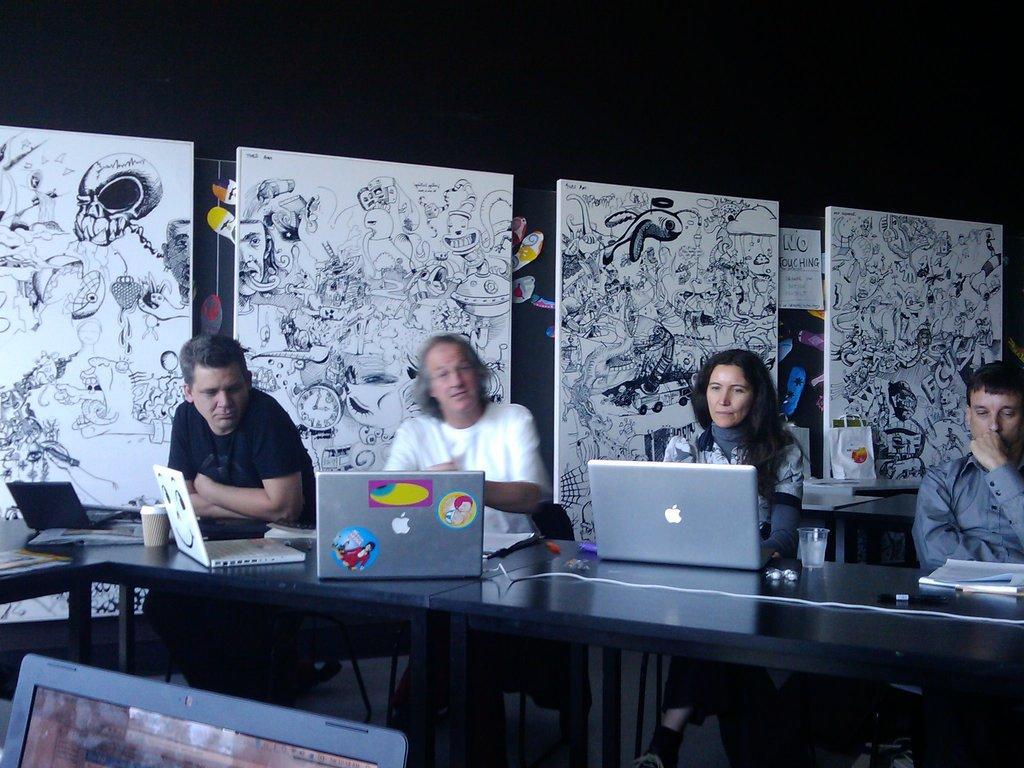Please provide a concise description of this image. In this image I can see few people are sitting and on this table I can see few laptops. I can also see few glasses and a book. In the background I can see sketches. 